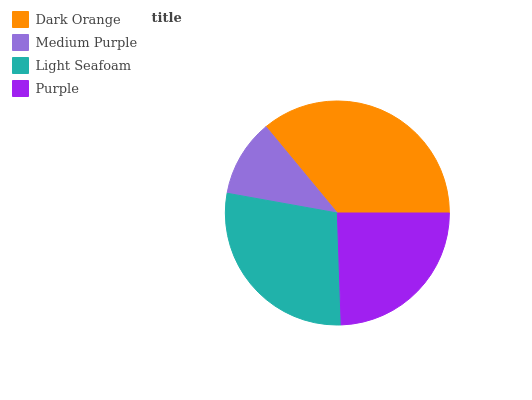Is Medium Purple the minimum?
Answer yes or no. Yes. Is Dark Orange the maximum?
Answer yes or no. Yes. Is Light Seafoam the minimum?
Answer yes or no. No. Is Light Seafoam the maximum?
Answer yes or no. No. Is Light Seafoam greater than Medium Purple?
Answer yes or no. Yes. Is Medium Purple less than Light Seafoam?
Answer yes or no. Yes. Is Medium Purple greater than Light Seafoam?
Answer yes or no. No. Is Light Seafoam less than Medium Purple?
Answer yes or no. No. Is Light Seafoam the high median?
Answer yes or no. Yes. Is Purple the low median?
Answer yes or no. Yes. Is Medium Purple the high median?
Answer yes or no. No. Is Light Seafoam the low median?
Answer yes or no. No. 